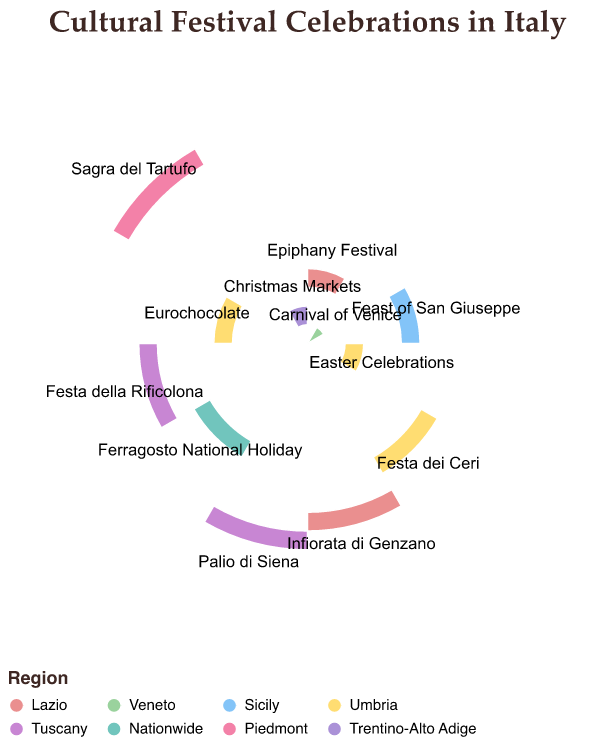What is the title of the Polar Chart? The title of the chart is usually a text displayed prominently at the top of the figure. Here, it reads "Cultural Festival Celebrations in Italy."
Answer: Cultural Festival Celebrations in Italy Which festival is celebrated nationwide in August? The polar chart shows different festivals distributed by months. The festival in August is labeled "Ferragosto National Holiday," and it covers the label "Nationwide" in its sector.
Answer: Ferragosto National Holiday How many festivals are held in Umbria? By examining the chart for the color associated with Umbria, which is given in the legend, and counting the corresponding sectors, we find that Umbria hosts three festivals: "Easter Celebrations," "Festa dei Ceri," and "Eurochocolate."
Answer: 3 Which months have festivals in Lazio? By matching the color used for Lazio (given in the legend) with the corresponding sectors in the chart, we discover that festivals in Lazio are celebrated in January and June: "Epiphany Festival" and "Infiorata di Genzano."
Answer: January and June Which region has a festival in December? By locating December along the circle’s axis and identifying the corresponding color and label, we see that the "Christmas Markets" in Trentino-Alto Adige are celebrated in December.
Answer: Trentino-Alto Adige Compare the number of festivals held in Tuscany and Umbria and determine which has more. By examining the legend for the colors representing Tuscany and Umbria, and then counting their corresponding sectors in the chart, we find Tuscany has two festivals ("Palio di Siena" and "Festa della Rificolona") while Umbria has three ("Easter Celebrations," "Festa dei Ceri," and "Eurochocolate"). Therefore, Umbria has more festivals.
Answer: Umbria has more What regions have festivals in April and October? First, locate April and October along the circle’s axis. Then find the festival label and corresponding color in these months. April shows "Easter Celebrations" in Umbria, and October shows "Eurochocolate" also in Umbria. Hence, both belong to the region Umbria.
Answer: Umbria Identify the festival taking place in March. Locate March along the polar chart and identify the label and festival name there. The chart shows "Feast of San Giuseppe" in March.
Answer: Feast of San Giuseppe How many festivals are celebrated in the first quarter of the year? The first quarter includes January, February, and March. Locate these months in the chart and note the festivals: January ("Epiphany Festival"), February ("Carnival of Venice"), and March ("Feast of San Giuseppe"). Count these to get the total.
Answer: 3 Which region features multiple festivals and what are their names? By examining the chart and corresponding region colors in the legend, Umbria has multiple festivals ("Easter Celebrations," "Festa dei Ceri," "Eurochocolate").
Answer: Umbria, and the festivals are "Easter Celebrations," "Festa dei Ceri," "Eurochocolate" 